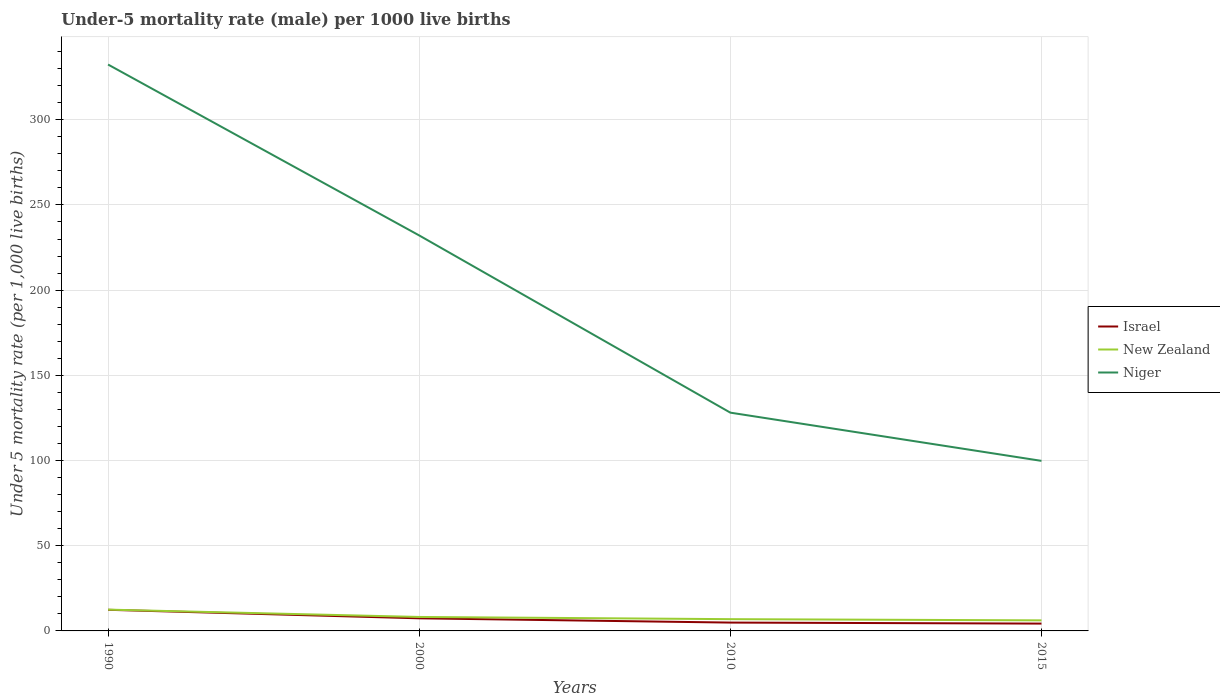Does the line corresponding to Niger intersect with the line corresponding to Israel?
Ensure brevity in your answer.  No. Across all years, what is the maximum under-five mortality rate in Israel?
Offer a terse response. 4.3. In which year was the under-five mortality rate in Niger maximum?
Ensure brevity in your answer.  2015. What is the total under-five mortality rate in Israel in the graph?
Keep it short and to the point. 0.6. What is the difference between the highest and the second highest under-five mortality rate in New Zealand?
Offer a terse response. 6.3. How many lines are there?
Offer a very short reply. 3. How many years are there in the graph?
Ensure brevity in your answer.  4. What is the difference between two consecutive major ticks on the Y-axis?
Ensure brevity in your answer.  50. Does the graph contain any zero values?
Keep it short and to the point. No. Does the graph contain grids?
Provide a short and direct response. Yes. Where does the legend appear in the graph?
Keep it short and to the point. Center right. How many legend labels are there?
Provide a succinct answer. 3. How are the legend labels stacked?
Your answer should be very brief. Vertical. What is the title of the graph?
Ensure brevity in your answer.  Under-5 mortality rate (male) per 1000 live births. What is the label or title of the X-axis?
Your answer should be compact. Years. What is the label or title of the Y-axis?
Provide a short and direct response. Under 5 mortality rate (per 1,0 live births). What is the Under 5 mortality rate (per 1,000 live births) of Israel in 1990?
Provide a short and direct response. 12.4. What is the Under 5 mortality rate (per 1,000 live births) in New Zealand in 1990?
Your answer should be compact. 12.5. What is the Under 5 mortality rate (per 1,000 live births) of Niger in 1990?
Offer a very short reply. 332.4. What is the Under 5 mortality rate (per 1,000 live births) in New Zealand in 2000?
Give a very brief answer. 8.2. What is the Under 5 mortality rate (per 1,000 live births) of Niger in 2000?
Offer a very short reply. 232.1. What is the Under 5 mortality rate (per 1,000 live births) of Israel in 2010?
Ensure brevity in your answer.  4.9. What is the Under 5 mortality rate (per 1,000 live births) of New Zealand in 2010?
Give a very brief answer. 6.9. What is the Under 5 mortality rate (per 1,000 live births) in Niger in 2010?
Offer a very short reply. 128.1. What is the Under 5 mortality rate (per 1,000 live births) in New Zealand in 2015?
Ensure brevity in your answer.  6.2. What is the Under 5 mortality rate (per 1,000 live births) of Niger in 2015?
Offer a terse response. 99.8. Across all years, what is the maximum Under 5 mortality rate (per 1,000 live births) in Israel?
Give a very brief answer. 12.4. Across all years, what is the maximum Under 5 mortality rate (per 1,000 live births) of Niger?
Your answer should be compact. 332.4. Across all years, what is the minimum Under 5 mortality rate (per 1,000 live births) in New Zealand?
Provide a succinct answer. 6.2. Across all years, what is the minimum Under 5 mortality rate (per 1,000 live births) of Niger?
Your answer should be very brief. 99.8. What is the total Under 5 mortality rate (per 1,000 live births) in New Zealand in the graph?
Provide a succinct answer. 33.8. What is the total Under 5 mortality rate (per 1,000 live births) in Niger in the graph?
Your response must be concise. 792.4. What is the difference between the Under 5 mortality rate (per 1,000 live births) of Israel in 1990 and that in 2000?
Offer a very short reply. 5. What is the difference between the Under 5 mortality rate (per 1,000 live births) of Niger in 1990 and that in 2000?
Offer a terse response. 100.3. What is the difference between the Under 5 mortality rate (per 1,000 live births) of Israel in 1990 and that in 2010?
Keep it short and to the point. 7.5. What is the difference between the Under 5 mortality rate (per 1,000 live births) in New Zealand in 1990 and that in 2010?
Offer a terse response. 5.6. What is the difference between the Under 5 mortality rate (per 1,000 live births) of Niger in 1990 and that in 2010?
Your answer should be very brief. 204.3. What is the difference between the Under 5 mortality rate (per 1,000 live births) in New Zealand in 1990 and that in 2015?
Keep it short and to the point. 6.3. What is the difference between the Under 5 mortality rate (per 1,000 live births) of Niger in 1990 and that in 2015?
Offer a terse response. 232.6. What is the difference between the Under 5 mortality rate (per 1,000 live births) of Israel in 2000 and that in 2010?
Keep it short and to the point. 2.5. What is the difference between the Under 5 mortality rate (per 1,000 live births) in New Zealand in 2000 and that in 2010?
Offer a very short reply. 1.3. What is the difference between the Under 5 mortality rate (per 1,000 live births) of Niger in 2000 and that in 2010?
Your answer should be very brief. 104. What is the difference between the Under 5 mortality rate (per 1,000 live births) in Israel in 2000 and that in 2015?
Give a very brief answer. 3.1. What is the difference between the Under 5 mortality rate (per 1,000 live births) of Niger in 2000 and that in 2015?
Provide a short and direct response. 132.3. What is the difference between the Under 5 mortality rate (per 1,000 live births) in Israel in 2010 and that in 2015?
Give a very brief answer. 0.6. What is the difference between the Under 5 mortality rate (per 1,000 live births) in New Zealand in 2010 and that in 2015?
Offer a terse response. 0.7. What is the difference between the Under 5 mortality rate (per 1,000 live births) of Niger in 2010 and that in 2015?
Provide a succinct answer. 28.3. What is the difference between the Under 5 mortality rate (per 1,000 live births) in Israel in 1990 and the Under 5 mortality rate (per 1,000 live births) in Niger in 2000?
Give a very brief answer. -219.7. What is the difference between the Under 5 mortality rate (per 1,000 live births) in New Zealand in 1990 and the Under 5 mortality rate (per 1,000 live births) in Niger in 2000?
Keep it short and to the point. -219.6. What is the difference between the Under 5 mortality rate (per 1,000 live births) of Israel in 1990 and the Under 5 mortality rate (per 1,000 live births) of New Zealand in 2010?
Your answer should be compact. 5.5. What is the difference between the Under 5 mortality rate (per 1,000 live births) in Israel in 1990 and the Under 5 mortality rate (per 1,000 live births) in Niger in 2010?
Give a very brief answer. -115.7. What is the difference between the Under 5 mortality rate (per 1,000 live births) of New Zealand in 1990 and the Under 5 mortality rate (per 1,000 live births) of Niger in 2010?
Offer a terse response. -115.6. What is the difference between the Under 5 mortality rate (per 1,000 live births) in Israel in 1990 and the Under 5 mortality rate (per 1,000 live births) in New Zealand in 2015?
Keep it short and to the point. 6.2. What is the difference between the Under 5 mortality rate (per 1,000 live births) in Israel in 1990 and the Under 5 mortality rate (per 1,000 live births) in Niger in 2015?
Your response must be concise. -87.4. What is the difference between the Under 5 mortality rate (per 1,000 live births) in New Zealand in 1990 and the Under 5 mortality rate (per 1,000 live births) in Niger in 2015?
Your answer should be compact. -87.3. What is the difference between the Under 5 mortality rate (per 1,000 live births) of Israel in 2000 and the Under 5 mortality rate (per 1,000 live births) of Niger in 2010?
Offer a terse response. -120.7. What is the difference between the Under 5 mortality rate (per 1,000 live births) of New Zealand in 2000 and the Under 5 mortality rate (per 1,000 live births) of Niger in 2010?
Give a very brief answer. -119.9. What is the difference between the Under 5 mortality rate (per 1,000 live births) of Israel in 2000 and the Under 5 mortality rate (per 1,000 live births) of New Zealand in 2015?
Make the answer very short. 1.2. What is the difference between the Under 5 mortality rate (per 1,000 live births) in Israel in 2000 and the Under 5 mortality rate (per 1,000 live births) in Niger in 2015?
Your answer should be very brief. -92.4. What is the difference between the Under 5 mortality rate (per 1,000 live births) of New Zealand in 2000 and the Under 5 mortality rate (per 1,000 live births) of Niger in 2015?
Make the answer very short. -91.6. What is the difference between the Under 5 mortality rate (per 1,000 live births) of Israel in 2010 and the Under 5 mortality rate (per 1,000 live births) of Niger in 2015?
Your answer should be very brief. -94.9. What is the difference between the Under 5 mortality rate (per 1,000 live births) in New Zealand in 2010 and the Under 5 mortality rate (per 1,000 live births) in Niger in 2015?
Your answer should be very brief. -92.9. What is the average Under 5 mortality rate (per 1,000 live births) in Israel per year?
Offer a very short reply. 7.25. What is the average Under 5 mortality rate (per 1,000 live births) in New Zealand per year?
Keep it short and to the point. 8.45. What is the average Under 5 mortality rate (per 1,000 live births) of Niger per year?
Provide a short and direct response. 198.1. In the year 1990, what is the difference between the Under 5 mortality rate (per 1,000 live births) in Israel and Under 5 mortality rate (per 1,000 live births) in New Zealand?
Your response must be concise. -0.1. In the year 1990, what is the difference between the Under 5 mortality rate (per 1,000 live births) of Israel and Under 5 mortality rate (per 1,000 live births) of Niger?
Offer a very short reply. -320. In the year 1990, what is the difference between the Under 5 mortality rate (per 1,000 live births) of New Zealand and Under 5 mortality rate (per 1,000 live births) of Niger?
Provide a short and direct response. -319.9. In the year 2000, what is the difference between the Under 5 mortality rate (per 1,000 live births) in Israel and Under 5 mortality rate (per 1,000 live births) in Niger?
Offer a terse response. -224.7. In the year 2000, what is the difference between the Under 5 mortality rate (per 1,000 live births) in New Zealand and Under 5 mortality rate (per 1,000 live births) in Niger?
Offer a very short reply. -223.9. In the year 2010, what is the difference between the Under 5 mortality rate (per 1,000 live births) in Israel and Under 5 mortality rate (per 1,000 live births) in New Zealand?
Give a very brief answer. -2. In the year 2010, what is the difference between the Under 5 mortality rate (per 1,000 live births) in Israel and Under 5 mortality rate (per 1,000 live births) in Niger?
Offer a very short reply. -123.2. In the year 2010, what is the difference between the Under 5 mortality rate (per 1,000 live births) in New Zealand and Under 5 mortality rate (per 1,000 live births) in Niger?
Provide a short and direct response. -121.2. In the year 2015, what is the difference between the Under 5 mortality rate (per 1,000 live births) in Israel and Under 5 mortality rate (per 1,000 live births) in Niger?
Your answer should be compact. -95.5. In the year 2015, what is the difference between the Under 5 mortality rate (per 1,000 live births) of New Zealand and Under 5 mortality rate (per 1,000 live births) of Niger?
Ensure brevity in your answer.  -93.6. What is the ratio of the Under 5 mortality rate (per 1,000 live births) in Israel in 1990 to that in 2000?
Give a very brief answer. 1.68. What is the ratio of the Under 5 mortality rate (per 1,000 live births) in New Zealand in 1990 to that in 2000?
Your response must be concise. 1.52. What is the ratio of the Under 5 mortality rate (per 1,000 live births) in Niger in 1990 to that in 2000?
Provide a succinct answer. 1.43. What is the ratio of the Under 5 mortality rate (per 1,000 live births) of Israel in 1990 to that in 2010?
Provide a succinct answer. 2.53. What is the ratio of the Under 5 mortality rate (per 1,000 live births) of New Zealand in 1990 to that in 2010?
Your answer should be compact. 1.81. What is the ratio of the Under 5 mortality rate (per 1,000 live births) in Niger in 1990 to that in 2010?
Your response must be concise. 2.59. What is the ratio of the Under 5 mortality rate (per 1,000 live births) in Israel in 1990 to that in 2015?
Ensure brevity in your answer.  2.88. What is the ratio of the Under 5 mortality rate (per 1,000 live births) of New Zealand in 1990 to that in 2015?
Provide a short and direct response. 2.02. What is the ratio of the Under 5 mortality rate (per 1,000 live births) of Niger in 1990 to that in 2015?
Provide a succinct answer. 3.33. What is the ratio of the Under 5 mortality rate (per 1,000 live births) in Israel in 2000 to that in 2010?
Your response must be concise. 1.51. What is the ratio of the Under 5 mortality rate (per 1,000 live births) of New Zealand in 2000 to that in 2010?
Ensure brevity in your answer.  1.19. What is the ratio of the Under 5 mortality rate (per 1,000 live births) in Niger in 2000 to that in 2010?
Give a very brief answer. 1.81. What is the ratio of the Under 5 mortality rate (per 1,000 live births) in Israel in 2000 to that in 2015?
Your answer should be very brief. 1.72. What is the ratio of the Under 5 mortality rate (per 1,000 live births) of New Zealand in 2000 to that in 2015?
Provide a succinct answer. 1.32. What is the ratio of the Under 5 mortality rate (per 1,000 live births) in Niger in 2000 to that in 2015?
Your answer should be compact. 2.33. What is the ratio of the Under 5 mortality rate (per 1,000 live births) of Israel in 2010 to that in 2015?
Offer a very short reply. 1.14. What is the ratio of the Under 5 mortality rate (per 1,000 live births) of New Zealand in 2010 to that in 2015?
Your response must be concise. 1.11. What is the ratio of the Under 5 mortality rate (per 1,000 live births) of Niger in 2010 to that in 2015?
Ensure brevity in your answer.  1.28. What is the difference between the highest and the second highest Under 5 mortality rate (per 1,000 live births) in Israel?
Give a very brief answer. 5. What is the difference between the highest and the second highest Under 5 mortality rate (per 1,000 live births) of Niger?
Offer a terse response. 100.3. What is the difference between the highest and the lowest Under 5 mortality rate (per 1,000 live births) in Israel?
Your response must be concise. 8.1. What is the difference between the highest and the lowest Under 5 mortality rate (per 1,000 live births) of Niger?
Keep it short and to the point. 232.6. 